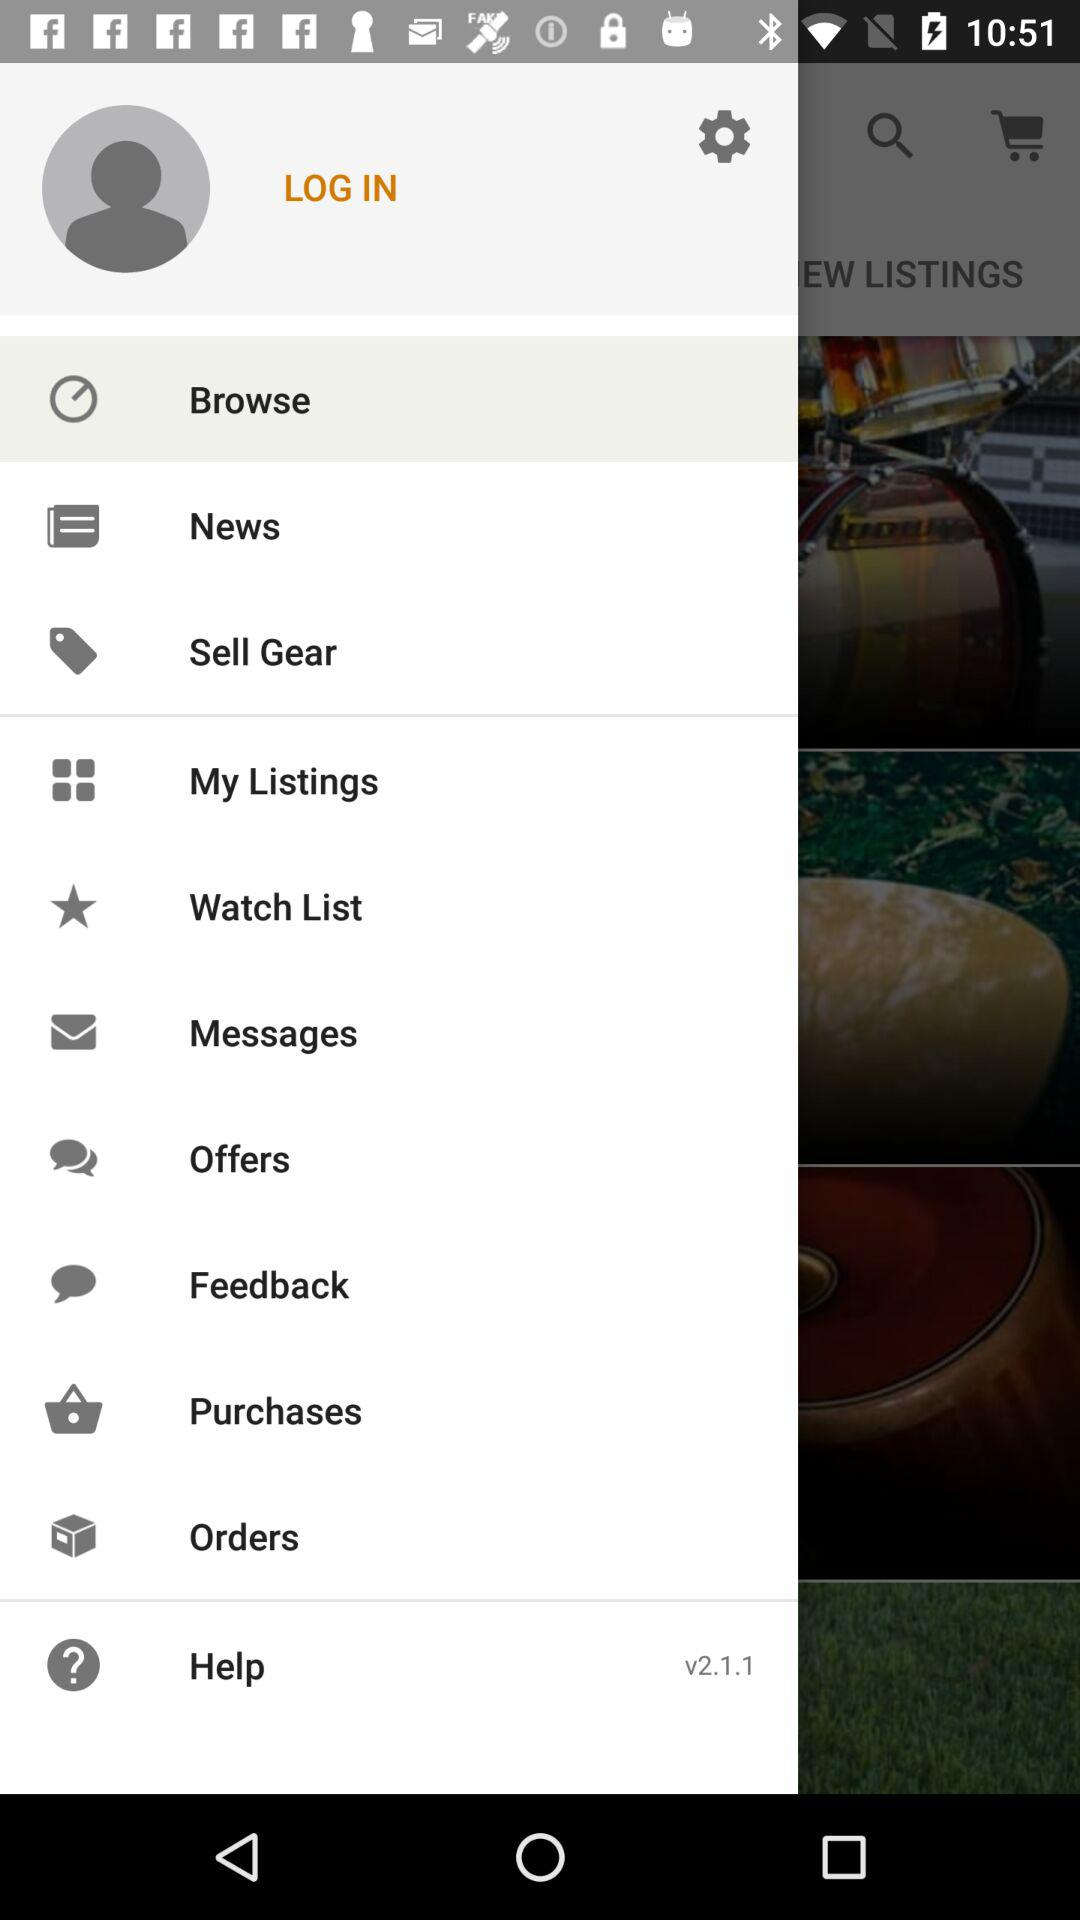What version is used? The version is v2.1.1. 